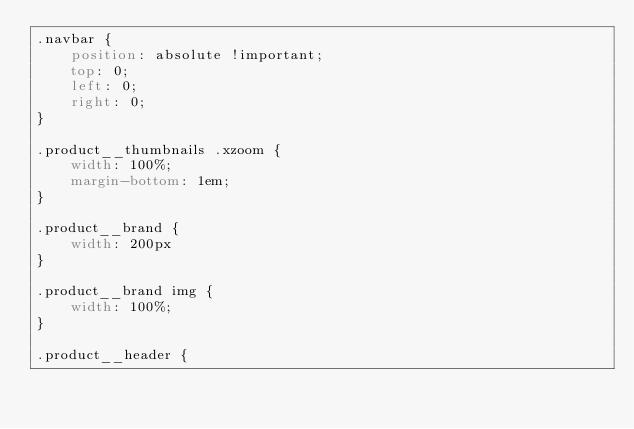Convert code to text. <code><loc_0><loc_0><loc_500><loc_500><_CSS_>.navbar {
    position: absolute !important;
    top: 0;
    left: 0;
    right: 0;
}

.product__thumbnails .xzoom {
    width: 100%;
    margin-bottom: 1em;
}

.product__brand {
    width: 200px
}

.product__brand img {
    width: 100%;
}

.product__header {</code> 